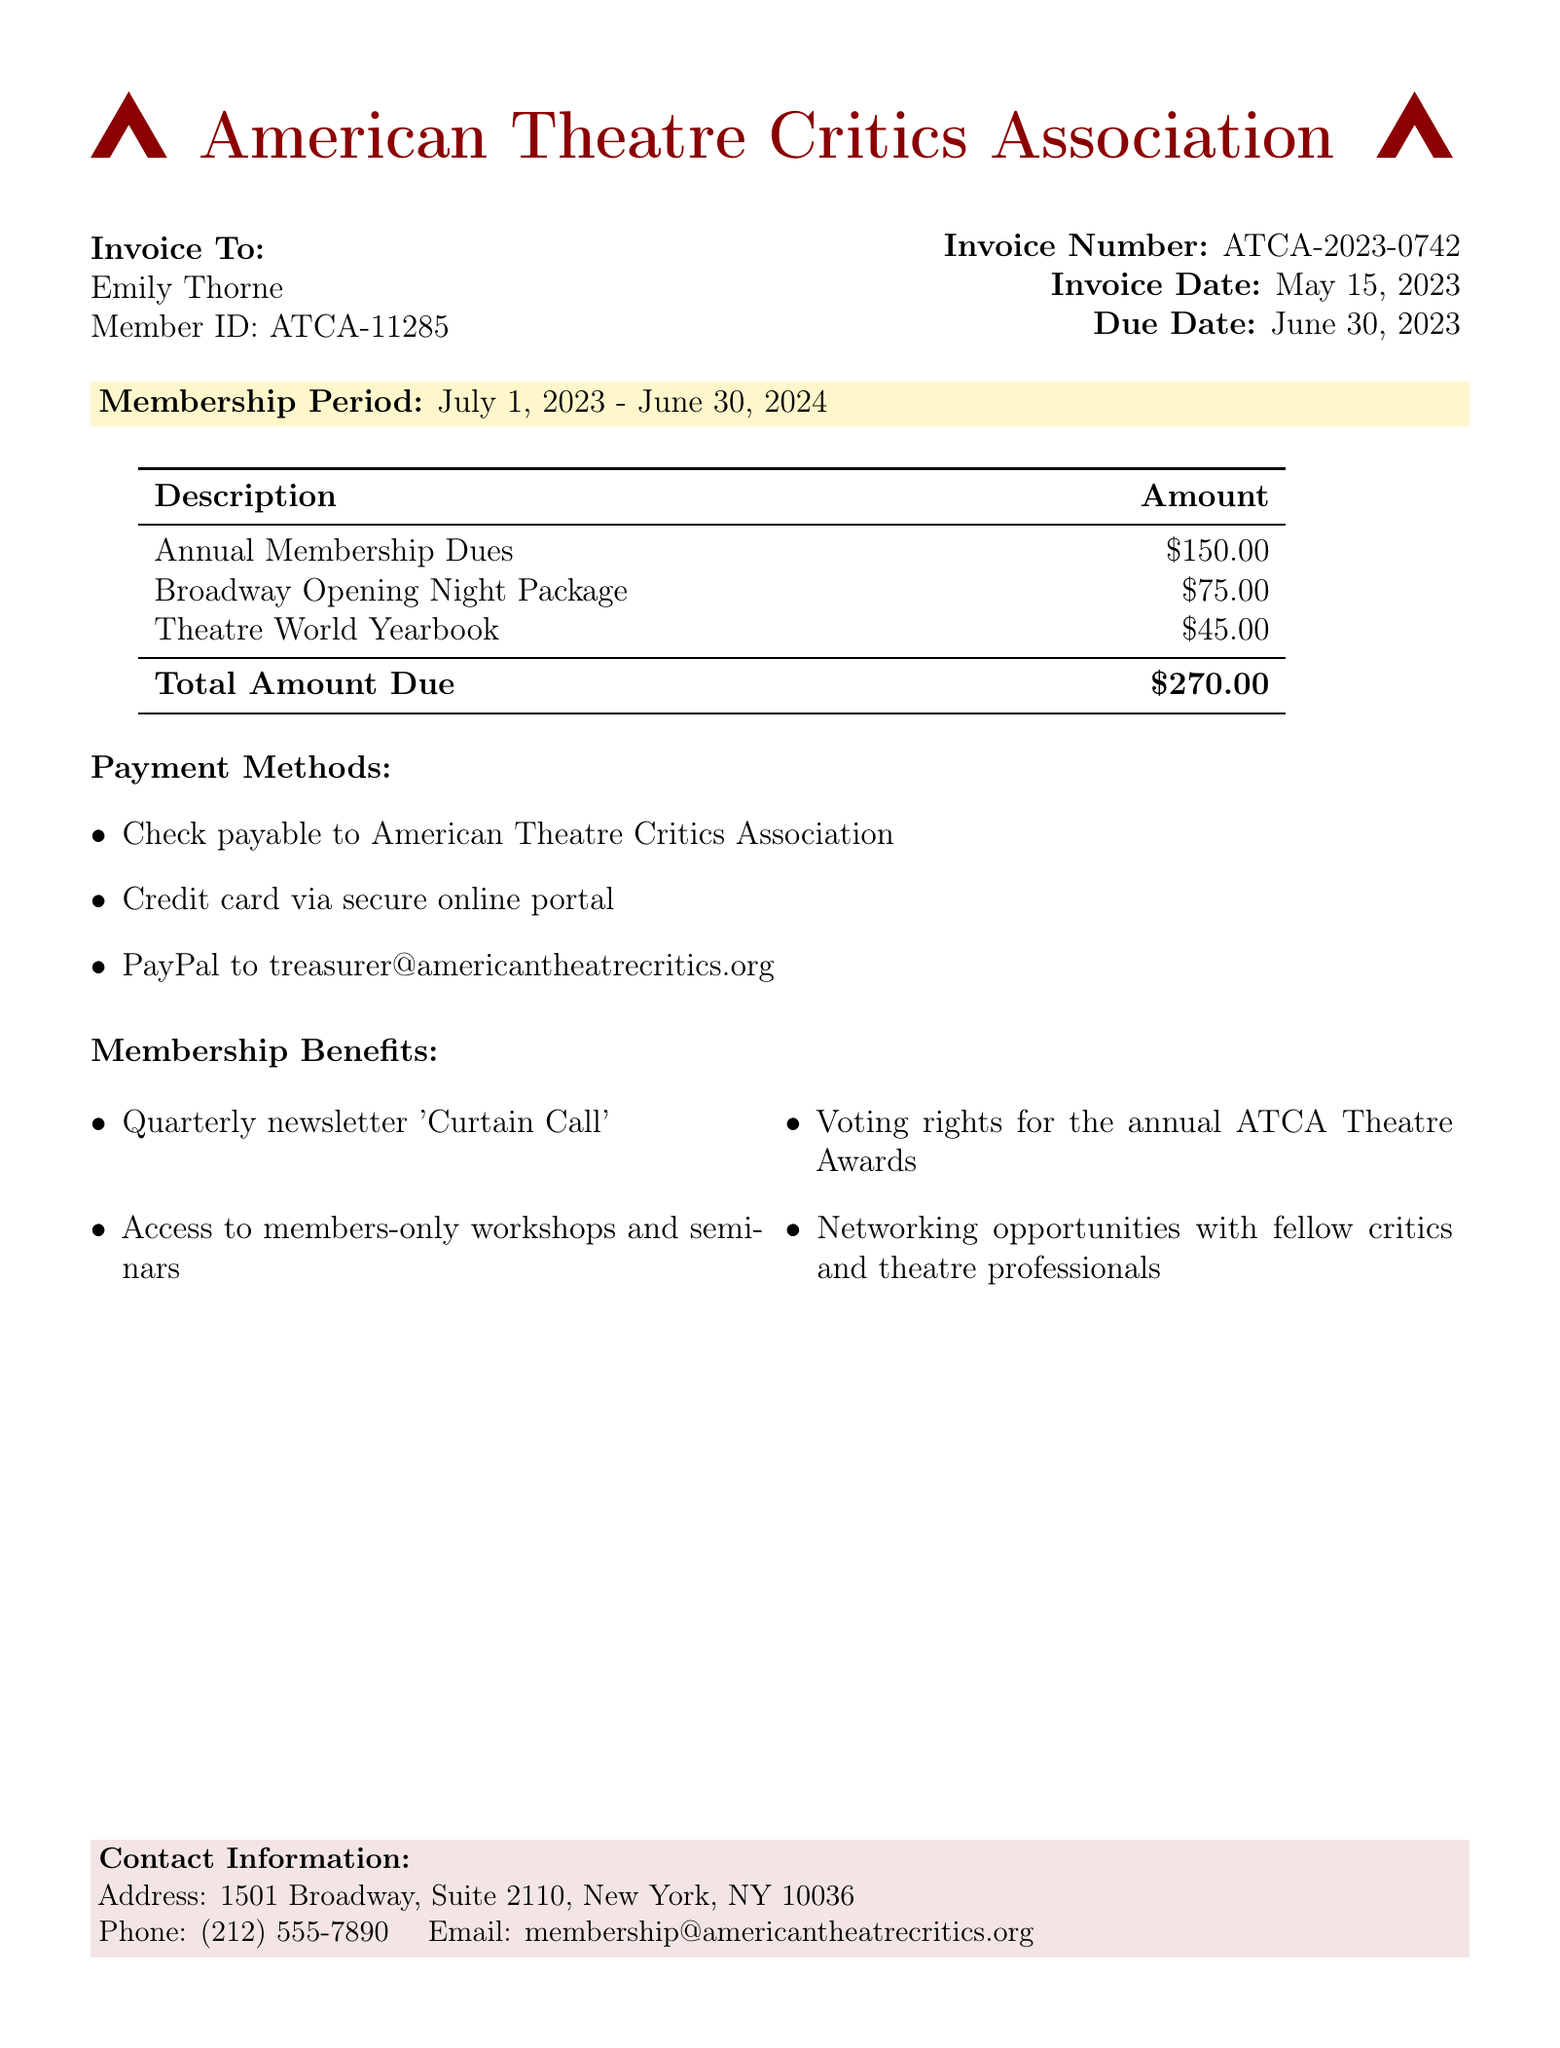What is the membership period? The membership period is specified in the document as the duration of active membership, which is July 1, 2023 - June 30, 2024.
Answer: July 1, 2023 - June 30, 2024 Who is the invoice addressed to? The document lists the recipient of the invoice, which is Emily Thorne.
Answer: Emily Thorne What is the total amount due? The total amount due is calculated from the individual amounts listed in the table, totaling $270.00.
Answer: $270.00 What are the annual membership dues? The document specifies the amount for annual membership dues as part of the invoice details.
Answer: $150.00 What is the due date for the invoice? The due date is the final date by which payment must be made, noted in the document as June 30, 2023.
Answer: June 30, 2023 What benefits do members receive? The document includes a list of membership benefits that are available to members of the American Theatre Critics Association.
Answer: Quarterly newsletter 'Curtain Call', Access to members-only workshops and seminars, Voting rights for the annual ATCA Theatre Awards, Networking opportunities with fellow critics and theatre professionals How can members pay the dues? The document provides various methods for payment, highlighting options available to the members for settling their dues.
Answer: Check, Credit card, PayPal What is the invoice number? The invoice number is a unique identifier for tracking the document and is listed in the invoice details.
Answer: ATCA-2023-0742 